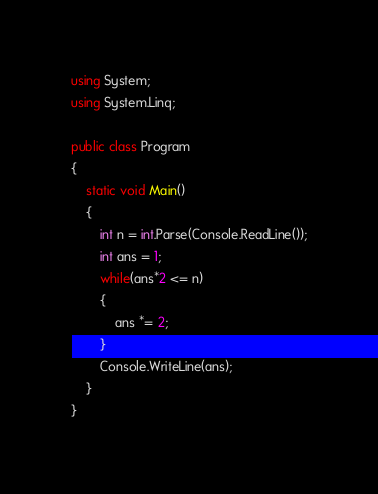Convert code to text. <code><loc_0><loc_0><loc_500><loc_500><_C#_>using System;
using System.Linq;

public class Program
{
    static void Main()
    {
        int n = int.Parse(Console.ReadLine());
        int ans = 1;
        while(ans*2 <= n)
        {
            ans *= 2;
        }
        Console.WriteLine(ans);
    }
}</code> 